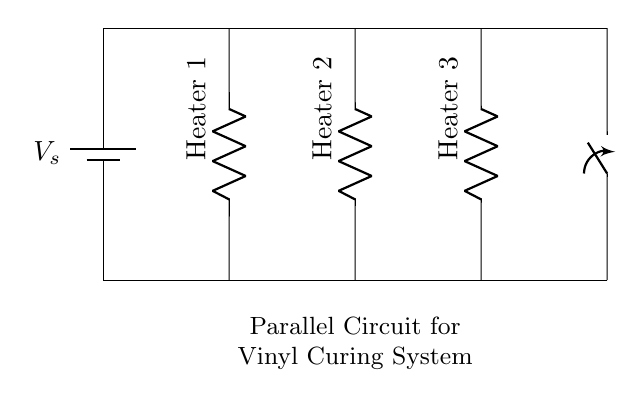what type of circuit is this? This circuit is a parallel circuit, as evidenced by the multiple branches (heating elements) connected directly to the same power source. In parallel circuits, each component has its own path for current.
Answer: parallel how many heating elements are in the circuit? There are three heating elements shown in the diagram. Each is represented by a resistor symbol labeled as Heater 1, Heater 2, and Heater 3.
Answer: three what is the function of the switch in this circuit? The switch in this circuit serves to control the flow of current to the entire arrangement of heating elements. When the switch is open, no current flows; when closed, current can flow through all heating elements.
Answer: control current if one heater is turned off, will the others still function? Yes, in a parallel circuit, if one component (like a heater) fails or is turned off, the other components can still operate independently, as they have their own paths for current.
Answer: yes what can you say about the voltage across each heater? Each heater experiences the same voltage as the source voltage, which can be labeled as V_s, since they are in parallel. The voltage across each component in a parallel circuit is equal to the source voltage.
Answer: V_s what is a key advantage of using a parallel circuit in this application? The key advantage of using a parallel circuit for the heating elements is redundancy; if one heater fails, the others continue to operate. This ensures continuous operation of the vinyl curing system.
Answer: redundancy how does the current behave in this circuit? In a parallel circuit, the total current is the sum of the currents through each individual branch. Each heating element draws its own current, determined by its resistance and the voltage across it.
Answer: sum of branch currents 